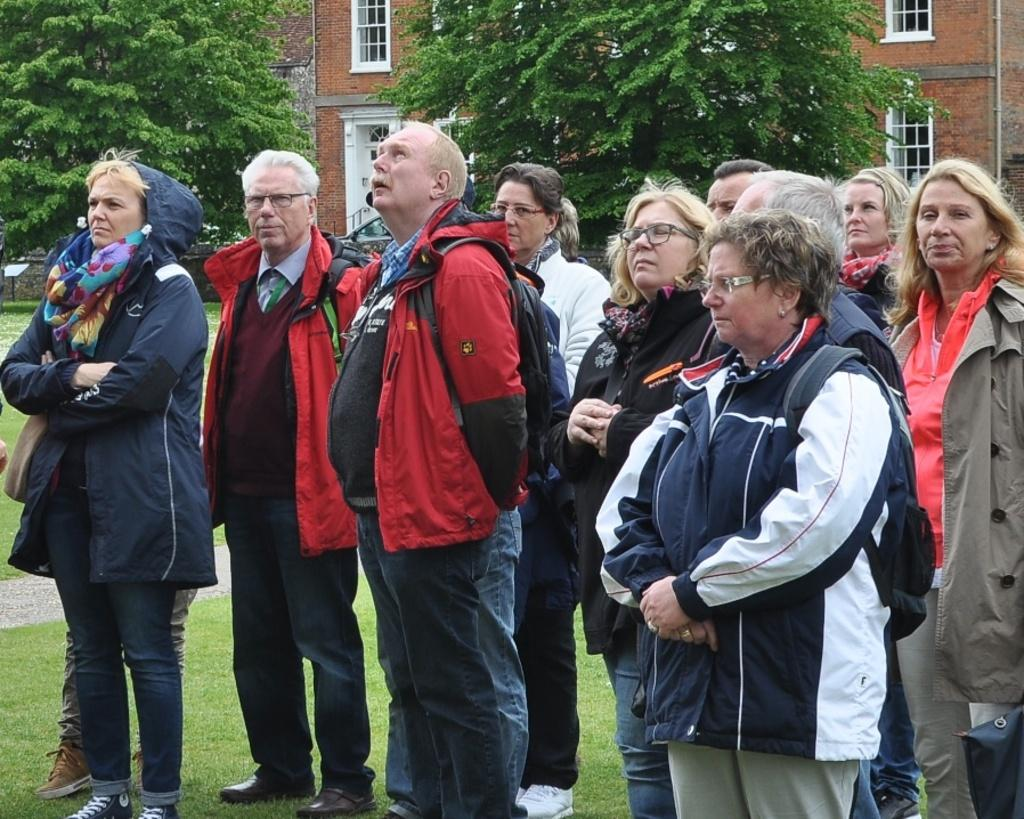What is the surface that the people are standing on in the image? The people are standing on the grass in the image. What can be seen in the background behind the people? There are trees and buildings visible in the background. How many hands are visible in the image? There is no mention of hands in the provided facts, so it cannot be determined how many hands are visible in the image. 